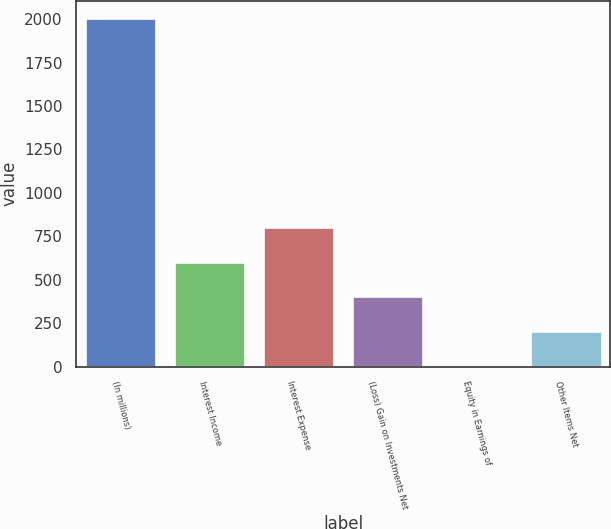<chart> <loc_0><loc_0><loc_500><loc_500><bar_chart><fcel>(In millions)<fcel>Interest Income<fcel>Interest Expense<fcel>(Loss) Gain on Investments Net<fcel>Equity in Earnings of<fcel>Other Items Net<nl><fcel>2007<fcel>603.92<fcel>804.36<fcel>403.48<fcel>2.6<fcel>203.04<nl></chart> 